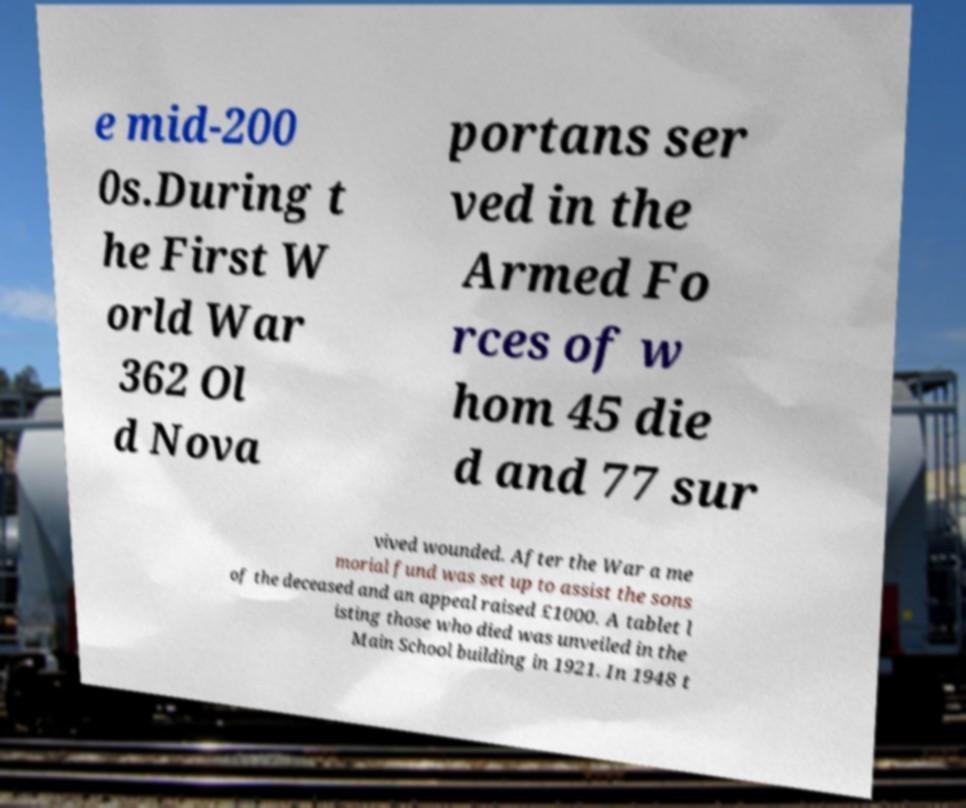Could you extract and type out the text from this image? e mid-200 0s.During t he First W orld War 362 Ol d Nova portans ser ved in the Armed Fo rces of w hom 45 die d and 77 sur vived wounded. After the War a me morial fund was set up to assist the sons of the deceased and an appeal raised £1000. A tablet l isting those who died was unveiled in the Main School building in 1921. In 1948 t 